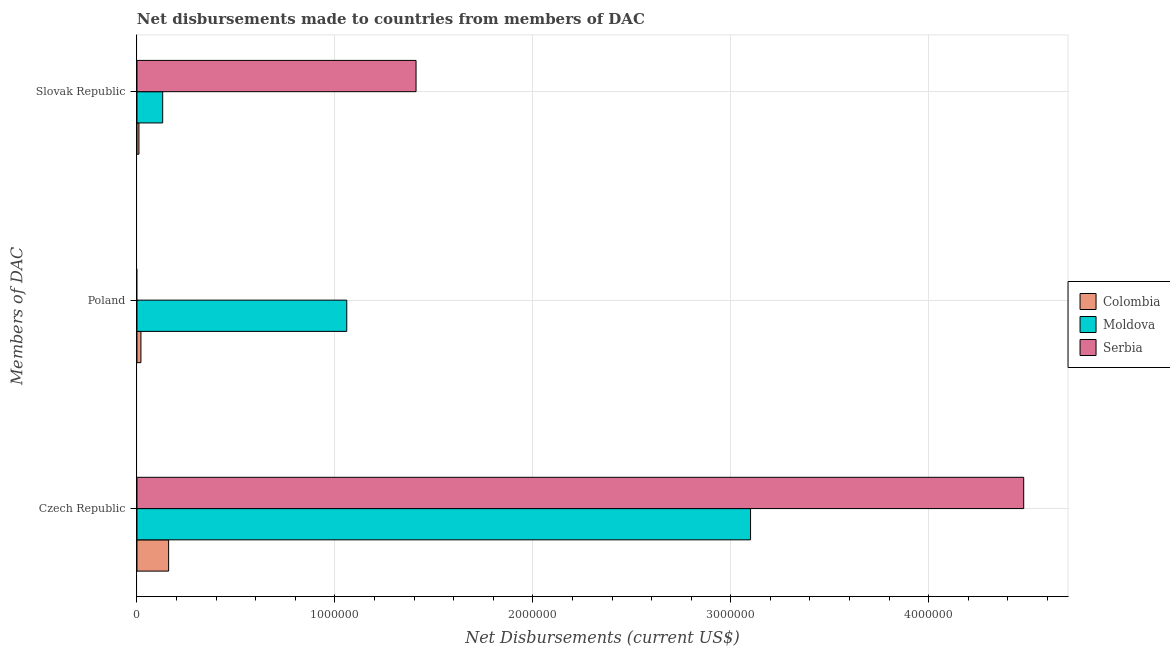How many different coloured bars are there?
Give a very brief answer. 3. Are the number of bars per tick equal to the number of legend labels?
Ensure brevity in your answer.  No. How many bars are there on the 2nd tick from the top?
Provide a short and direct response. 2. How many bars are there on the 2nd tick from the bottom?
Offer a terse response. 2. What is the label of the 3rd group of bars from the top?
Your answer should be very brief. Czech Republic. What is the net disbursements made by poland in Colombia?
Make the answer very short. 2.00e+04. Across all countries, what is the maximum net disbursements made by czech republic?
Make the answer very short. 4.48e+06. Across all countries, what is the minimum net disbursements made by poland?
Your answer should be compact. 0. In which country was the net disbursements made by slovak republic maximum?
Give a very brief answer. Serbia. What is the total net disbursements made by czech republic in the graph?
Keep it short and to the point. 7.74e+06. What is the difference between the net disbursements made by czech republic in Moldova and that in Serbia?
Offer a terse response. -1.38e+06. What is the difference between the net disbursements made by slovak republic in Serbia and the net disbursements made by czech republic in Colombia?
Provide a succinct answer. 1.25e+06. What is the difference between the net disbursements made by slovak republic and net disbursements made by poland in Moldova?
Make the answer very short. -9.30e+05. In how many countries, is the net disbursements made by slovak republic greater than 3400000 US$?
Provide a short and direct response. 0. What is the ratio of the net disbursements made by czech republic in Moldova to that in Serbia?
Provide a short and direct response. 0.69. Is the net disbursements made by slovak republic in Colombia less than that in Serbia?
Give a very brief answer. Yes. Is the difference between the net disbursements made by slovak republic in Moldova and Serbia greater than the difference between the net disbursements made by czech republic in Moldova and Serbia?
Give a very brief answer. Yes. What is the difference between the highest and the second highest net disbursements made by slovak republic?
Provide a short and direct response. 1.28e+06. What is the difference between the highest and the lowest net disbursements made by poland?
Keep it short and to the point. 1.06e+06. In how many countries, is the net disbursements made by poland greater than the average net disbursements made by poland taken over all countries?
Offer a terse response. 1. Is the sum of the net disbursements made by czech republic in Moldova and Colombia greater than the maximum net disbursements made by slovak republic across all countries?
Offer a very short reply. Yes. Is it the case that in every country, the sum of the net disbursements made by czech republic and net disbursements made by poland is greater than the net disbursements made by slovak republic?
Your answer should be compact. Yes. How many bars are there?
Give a very brief answer. 8. How many countries are there in the graph?
Keep it short and to the point. 3. What is the difference between two consecutive major ticks on the X-axis?
Your answer should be very brief. 1.00e+06. Where does the legend appear in the graph?
Keep it short and to the point. Center right. How many legend labels are there?
Offer a very short reply. 3. What is the title of the graph?
Your answer should be compact. Net disbursements made to countries from members of DAC. What is the label or title of the X-axis?
Your response must be concise. Net Disbursements (current US$). What is the label or title of the Y-axis?
Your response must be concise. Members of DAC. What is the Net Disbursements (current US$) in Colombia in Czech Republic?
Make the answer very short. 1.60e+05. What is the Net Disbursements (current US$) in Moldova in Czech Republic?
Your response must be concise. 3.10e+06. What is the Net Disbursements (current US$) of Serbia in Czech Republic?
Your answer should be very brief. 4.48e+06. What is the Net Disbursements (current US$) in Colombia in Poland?
Offer a terse response. 2.00e+04. What is the Net Disbursements (current US$) of Moldova in Poland?
Give a very brief answer. 1.06e+06. What is the Net Disbursements (current US$) in Moldova in Slovak Republic?
Offer a terse response. 1.30e+05. What is the Net Disbursements (current US$) of Serbia in Slovak Republic?
Offer a very short reply. 1.41e+06. Across all Members of DAC, what is the maximum Net Disbursements (current US$) of Colombia?
Keep it short and to the point. 1.60e+05. Across all Members of DAC, what is the maximum Net Disbursements (current US$) in Moldova?
Give a very brief answer. 3.10e+06. Across all Members of DAC, what is the maximum Net Disbursements (current US$) of Serbia?
Offer a very short reply. 4.48e+06. Across all Members of DAC, what is the minimum Net Disbursements (current US$) of Colombia?
Your answer should be compact. 10000. Across all Members of DAC, what is the minimum Net Disbursements (current US$) of Moldova?
Offer a very short reply. 1.30e+05. What is the total Net Disbursements (current US$) of Moldova in the graph?
Give a very brief answer. 4.29e+06. What is the total Net Disbursements (current US$) in Serbia in the graph?
Keep it short and to the point. 5.89e+06. What is the difference between the Net Disbursements (current US$) of Moldova in Czech Republic and that in Poland?
Your answer should be very brief. 2.04e+06. What is the difference between the Net Disbursements (current US$) in Colombia in Czech Republic and that in Slovak Republic?
Offer a terse response. 1.50e+05. What is the difference between the Net Disbursements (current US$) in Moldova in Czech Republic and that in Slovak Republic?
Ensure brevity in your answer.  2.97e+06. What is the difference between the Net Disbursements (current US$) in Serbia in Czech Republic and that in Slovak Republic?
Offer a very short reply. 3.07e+06. What is the difference between the Net Disbursements (current US$) of Moldova in Poland and that in Slovak Republic?
Give a very brief answer. 9.30e+05. What is the difference between the Net Disbursements (current US$) of Colombia in Czech Republic and the Net Disbursements (current US$) of Moldova in Poland?
Your response must be concise. -9.00e+05. What is the difference between the Net Disbursements (current US$) in Colombia in Czech Republic and the Net Disbursements (current US$) in Moldova in Slovak Republic?
Your response must be concise. 3.00e+04. What is the difference between the Net Disbursements (current US$) of Colombia in Czech Republic and the Net Disbursements (current US$) of Serbia in Slovak Republic?
Keep it short and to the point. -1.25e+06. What is the difference between the Net Disbursements (current US$) of Moldova in Czech Republic and the Net Disbursements (current US$) of Serbia in Slovak Republic?
Your answer should be very brief. 1.69e+06. What is the difference between the Net Disbursements (current US$) of Colombia in Poland and the Net Disbursements (current US$) of Serbia in Slovak Republic?
Your answer should be compact. -1.39e+06. What is the difference between the Net Disbursements (current US$) in Moldova in Poland and the Net Disbursements (current US$) in Serbia in Slovak Republic?
Your answer should be very brief. -3.50e+05. What is the average Net Disbursements (current US$) in Colombia per Members of DAC?
Your answer should be very brief. 6.33e+04. What is the average Net Disbursements (current US$) in Moldova per Members of DAC?
Ensure brevity in your answer.  1.43e+06. What is the average Net Disbursements (current US$) in Serbia per Members of DAC?
Offer a very short reply. 1.96e+06. What is the difference between the Net Disbursements (current US$) of Colombia and Net Disbursements (current US$) of Moldova in Czech Republic?
Ensure brevity in your answer.  -2.94e+06. What is the difference between the Net Disbursements (current US$) in Colombia and Net Disbursements (current US$) in Serbia in Czech Republic?
Provide a short and direct response. -4.32e+06. What is the difference between the Net Disbursements (current US$) in Moldova and Net Disbursements (current US$) in Serbia in Czech Republic?
Make the answer very short. -1.38e+06. What is the difference between the Net Disbursements (current US$) in Colombia and Net Disbursements (current US$) in Moldova in Poland?
Make the answer very short. -1.04e+06. What is the difference between the Net Disbursements (current US$) of Colombia and Net Disbursements (current US$) of Serbia in Slovak Republic?
Provide a succinct answer. -1.40e+06. What is the difference between the Net Disbursements (current US$) of Moldova and Net Disbursements (current US$) of Serbia in Slovak Republic?
Ensure brevity in your answer.  -1.28e+06. What is the ratio of the Net Disbursements (current US$) of Moldova in Czech Republic to that in Poland?
Your response must be concise. 2.92. What is the ratio of the Net Disbursements (current US$) of Moldova in Czech Republic to that in Slovak Republic?
Keep it short and to the point. 23.85. What is the ratio of the Net Disbursements (current US$) in Serbia in Czech Republic to that in Slovak Republic?
Your response must be concise. 3.18. What is the ratio of the Net Disbursements (current US$) in Colombia in Poland to that in Slovak Republic?
Offer a terse response. 2. What is the ratio of the Net Disbursements (current US$) in Moldova in Poland to that in Slovak Republic?
Your response must be concise. 8.15. What is the difference between the highest and the second highest Net Disbursements (current US$) of Moldova?
Your answer should be compact. 2.04e+06. What is the difference between the highest and the lowest Net Disbursements (current US$) in Colombia?
Provide a succinct answer. 1.50e+05. What is the difference between the highest and the lowest Net Disbursements (current US$) of Moldova?
Provide a short and direct response. 2.97e+06. What is the difference between the highest and the lowest Net Disbursements (current US$) in Serbia?
Keep it short and to the point. 4.48e+06. 